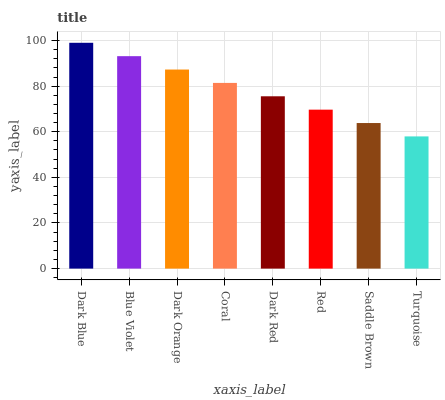Is Turquoise the minimum?
Answer yes or no. Yes. Is Dark Blue the maximum?
Answer yes or no. Yes. Is Blue Violet the minimum?
Answer yes or no. No. Is Blue Violet the maximum?
Answer yes or no. No. Is Dark Blue greater than Blue Violet?
Answer yes or no. Yes. Is Blue Violet less than Dark Blue?
Answer yes or no. Yes. Is Blue Violet greater than Dark Blue?
Answer yes or no. No. Is Dark Blue less than Blue Violet?
Answer yes or no. No. Is Coral the high median?
Answer yes or no. Yes. Is Dark Red the low median?
Answer yes or no. Yes. Is Saddle Brown the high median?
Answer yes or no. No. Is Blue Violet the low median?
Answer yes or no. No. 